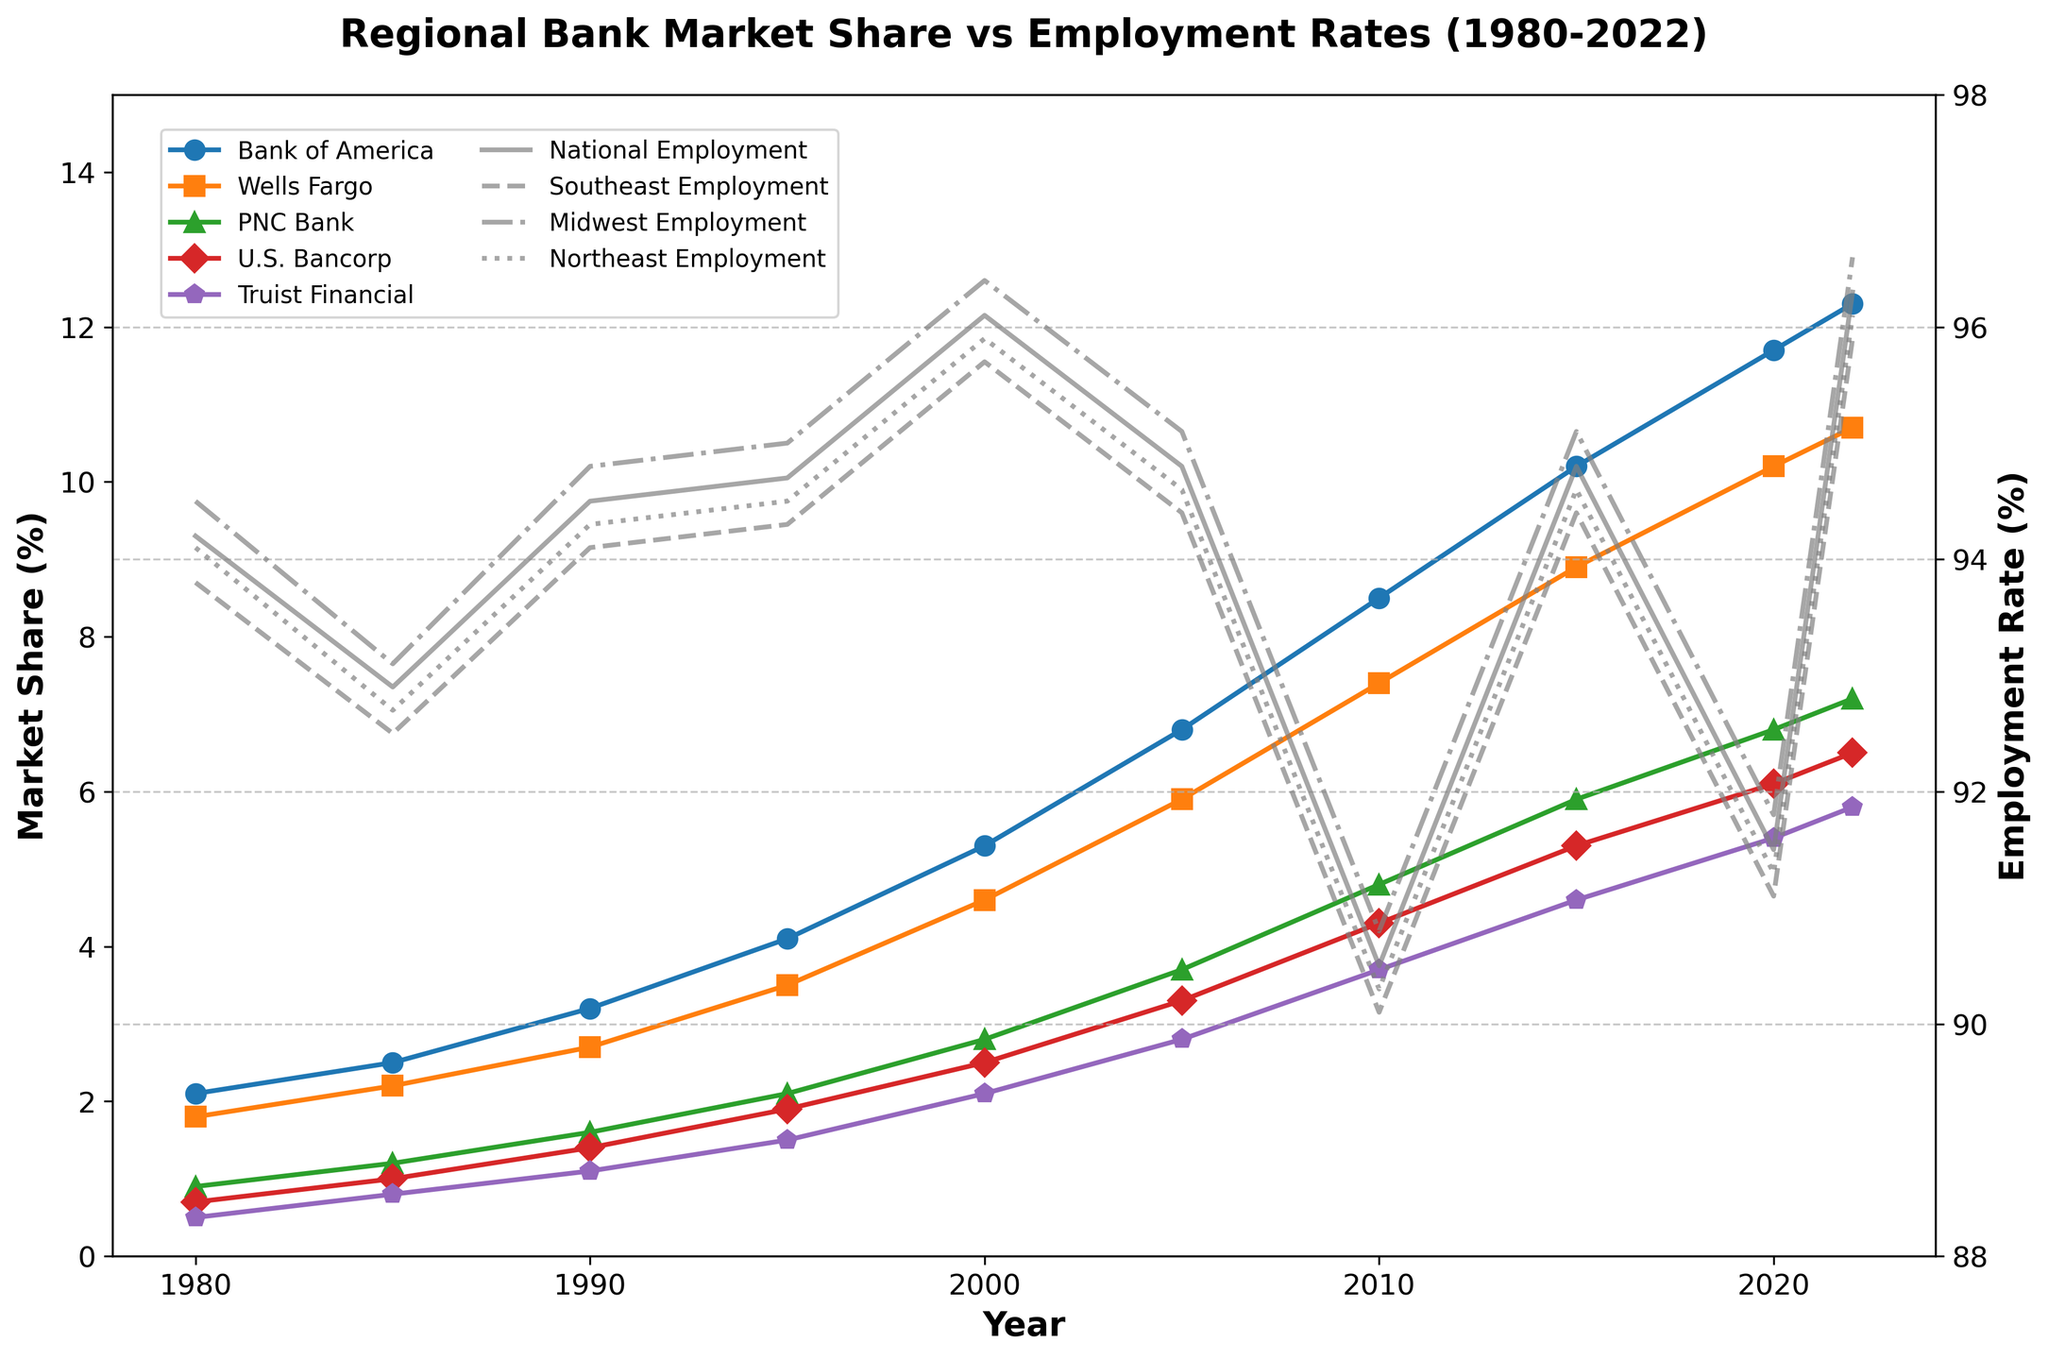How has the Bank of America's market share trended from 1980 to 2022? To determine the trend of Bank of America's market share, observe its line, which starts at 2.1% in 1980 and rises steadily to 12.3% in 2022.
Answer: increasing Which bank had the highest market share in 2022? Look at the multiple colored lines for different banks in 2022 and note which line is highest. Bank of America shows the highest market share in 2022 at 12.3%.
Answer: Bank of America What is the difference in market share between Wells Fargo and Truist Financial in 2020? Find the market share for Wells Fargo and Truist Financial in 2020. Wells Fargo is at 10.2%, and Truist Financial is at 5.4%. The difference is 10.2% - 5.4% = 4.8%.
Answer: 4.8% Compare the Midwest and Southeast employment rates in 2010. Which region had a higher rate? Check the employment rate lines for Midwest and Southeast in 2010. Midwest is at 90.8%, while Southeast is at 90.1%. Midwest has a higher rate.
Answer: Midwest What is the average national employment rate from 1980 to 2022? Sum the national employment rates for all years and divide by the number of years: (94.2 + 92.9 + 94.5 + 94.7 + 96.1 + 94.8 + 90.5 + 94.8 + 91.5 + 96.3) / 10 = 94.03%.
Answer: 94.03% Which region saw the lowest employment rate during the period? Scan the employment rate lines to find the lowest point. The Southeast in 2010 dropped to 90.1%, the lowest rate observed.
Answer: Southeast What's the overall trend in employment rates in the Northeast region from 1980 to 2022? Track the Northeast employment rate line starting from 1980 to 2022. It generally remains stable, fluctuates slightly but does not show a clear upward or downward trend.
Answer: stable How much did the market share of U.S. Bancorp increase from 1980 to 2020? Subtract U.S. Bancorp's market share in 1980 (0.7%) from its market share in 2020 (6.1%). The increase is 6.1% - 0.7% = 5.4%.
Answer: 5.4% Which year shows a major dip in national employment rate, and what might have caused it? Notice the major dip around 2010. The national employment rate drops to 90.5%, likely due to the aftermath of the 2008 financial crisis and the recession that followed.
Answer: 2010 Compare the market share growth rates between PNC Bank and Truist Financial from 2000 to 2022. Which bank grew faster? Calculate the differences from 2000 to 2022 for each: PNC Bank (7.2% - 2.8% = 4.4%) and Truist Financial (5.8% - 2.1% = 3.7%). PNC Bank had a growth rate of 4.4%, faster than Truist Financial's 3.7%.
Answer: PNC Bank 